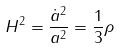Convert formula to latex. <formula><loc_0><loc_0><loc_500><loc_500>H ^ { 2 } = \frac { \dot { a } ^ { 2 } } { a ^ { 2 } } = \frac { 1 } { 3 } \rho</formula> 